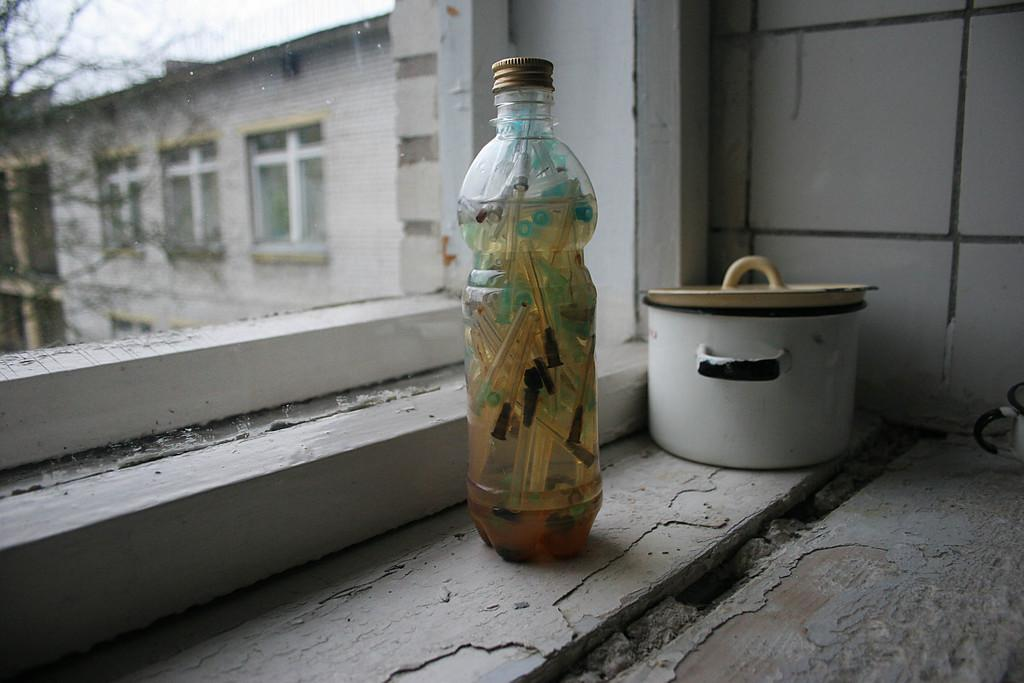What object can be seen in the image that is typically used for holding liquids? There is a bottle in the image. What object can be seen in the image that is typically used for eating or cooking? There is an utensil in the image. What can be seen in the distance in the image? There is a building and a tree in the background of the image. What type of joke is being told by the tree in the background of the image? There is no joke being told by the tree in the background of the image, as trees do not have the ability to tell jokes. 